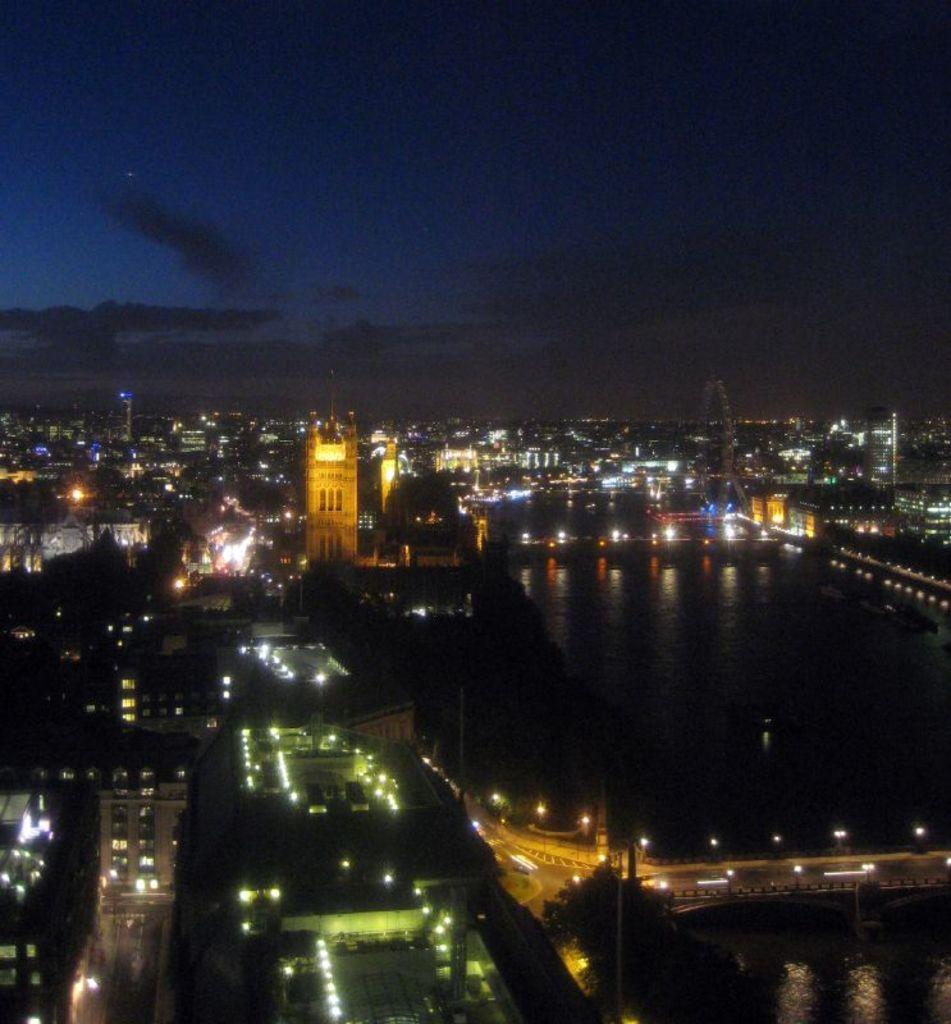Describe this image in one or two sentences. In this image we can see a night view. There are group of buildings and we can see the lights. In the middle we can see the water. At the top we can see the sky. 